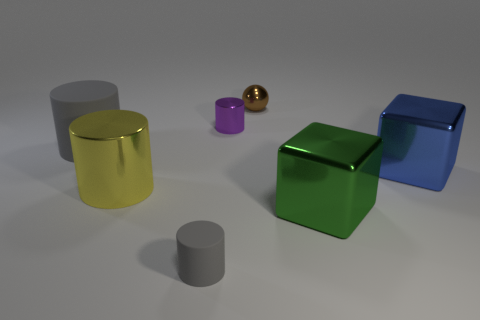Subtract all big rubber cylinders. How many cylinders are left? 3 Subtract all blocks. How many objects are left? 5 Subtract 1 balls. How many balls are left? 0 Subtract all green cubes. Subtract all cyan cylinders. How many cubes are left? 1 Subtract all blue spheres. How many yellow cylinders are left? 1 Subtract all large yellow things. Subtract all tiny purple cylinders. How many objects are left? 5 Add 1 purple metallic things. How many purple metallic things are left? 2 Add 1 small green metal things. How many small green metal things exist? 1 Add 1 purple metal cylinders. How many objects exist? 8 Subtract all yellow cylinders. How many cylinders are left? 3 